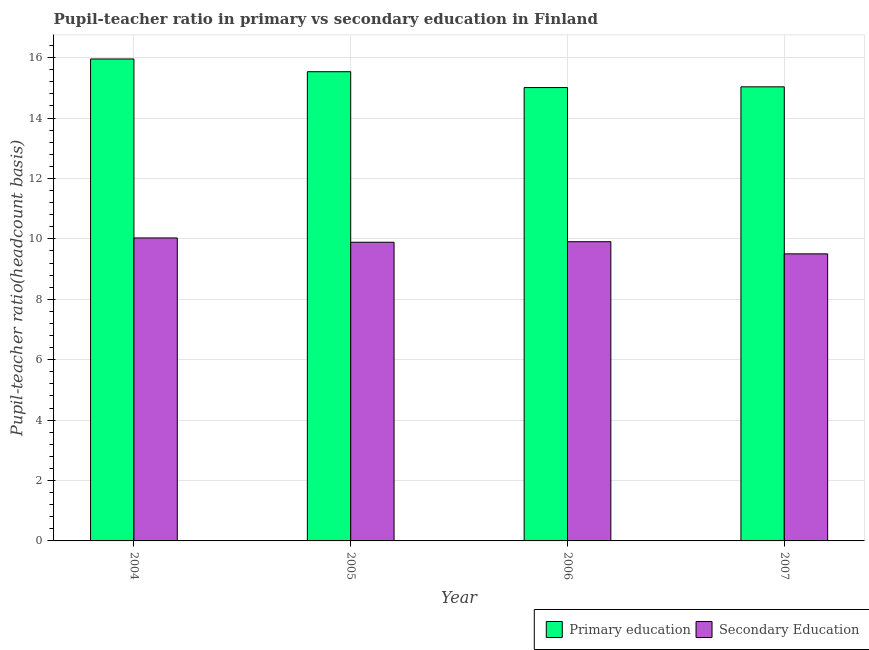How many groups of bars are there?
Offer a very short reply. 4. How many bars are there on the 3rd tick from the left?
Provide a short and direct response. 2. How many bars are there on the 3rd tick from the right?
Give a very brief answer. 2. What is the pupil-teacher ratio in primary education in 2005?
Make the answer very short. 15.53. Across all years, what is the maximum pupil teacher ratio on secondary education?
Make the answer very short. 10.03. Across all years, what is the minimum pupil-teacher ratio in primary education?
Give a very brief answer. 15.01. In which year was the pupil-teacher ratio in primary education maximum?
Ensure brevity in your answer.  2004. What is the total pupil-teacher ratio in primary education in the graph?
Your answer should be very brief. 61.53. What is the difference between the pupil-teacher ratio in primary education in 2004 and that in 2006?
Your response must be concise. 0.95. What is the difference between the pupil teacher ratio on secondary education in 2005 and the pupil-teacher ratio in primary education in 2007?
Your answer should be very brief. 0.38. What is the average pupil teacher ratio on secondary education per year?
Provide a short and direct response. 9.83. In how many years, is the pupil teacher ratio on secondary education greater than 1.6?
Your answer should be compact. 4. What is the ratio of the pupil-teacher ratio in primary education in 2004 to that in 2006?
Make the answer very short. 1.06. Is the pupil teacher ratio on secondary education in 2004 less than that in 2007?
Offer a terse response. No. What is the difference between the highest and the second highest pupil teacher ratio on secondary education?
Offer a terse response. 0.12. What is the difference between the highest and the lowest pupil teacher ratio on secondary education?
Your response must be concise. 0.53. What does the 2nd bar from the right in 2007 represents?
Keep it short and to the point. Primary education. How many years are there in the graph?
Provide a short and direct response. 4. Are the values on the major ticks of Y-axis written in scientific E-notation?
Give a very brief answer. No. Where does the legend appear in the graph?
Offer a very short reply. Bottom right. How many legend labels are there?
Provide a short and direct response. 2. What is the title of the graph?
Provide a short and direct response. Pupil-teacher ratio in primary vs secondary education in Finland. What is the label or title of the Y-axis?
Your answer should be very brief. Pupil-teacher ratio(headcount basis). What is the Pupil-teacher ratio(headcount basis) of Primary education in 2004?
Provide a short and direct response. 15.96. What is the Pupil-teacher ratio(headcount basis) in Secondary Education in 2004?
Keep it short and to the point. 10.03. What is the Pupil-teacher ratio(headcount basis) of Primary education in 2005?
Provide a short and direct response. 15.53. What is the Pupil-teacher ratio(headcount basis) of Secondary Education in 2005?
Ensure brevity in your answer.  9.89. What is the Pupil-teacher ratio(headcount basis) of Primary education in 2006?
Your response must be concise. 15.01. What is the Pupil-teacher ratio(headcount basis) in Secondary Education in 2006?
Your response must be concise. 9.91. What is the Pupil-teacher ratio(headcount basis) in Primary education in 2007?
Provide a succinct answer. 15.03. What is the Pupil-teacher ratio(headcount basis) of Secondary Education in 2007?
Provide a short and direct response. 9.5. Across all years, what is the maximum Pupil-teacher ratio(headcount basis) in Primary education?
Your answer should be compact. 15.96. Across all years, what is the maximum Pupil-teacher ratio(headcount basis) of Secondary Education?
Provide a short and direct response. 10.03. Across all years, what is the minimum Pupil-teacher ratio(headcount basis) of Primary education?
Provide a succinct answer. 15.01. Across all years, what is the minimum Pupil-teacher ratio(headcount basis) in Secondary Education?
Ensure brevity in your answer.  9.5. What is the total Pupil-teacher ratio(headcount basis) in Primary education in the graph?
Provide a short and direct response. 61.53. What is the total Pupil-teacher ratio(headcount basis) in Secondary Education in the graph?
Offer a terse response. 39.33. What is the difference between the Pupil-teacher ratio(headcount basis) in Primary education in 2004 and that in 2005?
Provide a succinct answer. 0.42. What is the difference between the Pupil-teacher ratio(headcount basis) of Secondary Education in 2004 and that in 2005?
Give a very brief answer. 0.14. What is the difference between the Pupil-teacher ratio(headcount basis) of Primary education in 2004 and that in 2006?
Provide a short and direct response. 0.95. What is the difference between the Pupil-teacher ratio(headcount basis) of Secondary Education in 2004 and that in 2006?
Keep it short and to the point. 0.12. What is the difference between the Pupil-teacher ratio(headcount basis) of Primary education in 2004 and that in 2007?
Give a very brief answer. 0.92. What is the difference between the Pupil-teacher ratio(headcount basis) in Secondary Education in 2004 and that in 2007?
Offer a very short reply. 0.53. What is the difference between the Pupil-teacher ratio(headcount basis) in Primary education in 2005 and that in 2006?
Offer a terse response. 0.52. What is the difference between the Pupil-teacher ratio(headcount basis) of Secondary Education in 2005 and that in 2006?
Provide a short and direct response. -0.02. What is the difference between the Pupil-teacher ratio(headcount basis) in Primary education in 2005 and that in 2007?
Your response must be concise. 0.5. What is the difference between the Pupil-teacher ratio(headcount basis) in Secondary Education in 2005 and that in 2007?
Your response must be concise. 0.38. What is the difference between the Pupil-teacher ratio(headcount basis) of Primary education in 2006 and that in 2007?
Provide a succinct answer. -0.02. What is the difference between the Pupil-teacher ratio(headcount basis) in Secondary Education in 2006 and that in 2007?
Give a very brief answer. 0.4. What is the difference between the Pupil-teacher ratio(headcount basis) of Primary education in 2004 and the Pupil-teacher ratio(headcount basis) of Secondary Education in 2005?
Make the answer very short. 6.07. What is the difference between the Pupil-teacher ratio(headcount basis) of Primary education in 2004 and the Pupil-teacher ratio(headcount basis) of Secondary Education in 2006?
Give a very brief answer. 6.05. What is the difference between the Pupil-teacher ratio(headcount basis) in Primary education in 2004 and the Pupil-teacher ratio(headcount basis) in Secondary Education in 2007?
Keep it short and to the point. 6.45. What is the difference between the Pupil-teacher ratio(headcount basis) in Primary education in 2005 and the Pupil-teacher ratio(headcount basis) in Secondary Education in 2006?
Your answer should be compact. 5.63. What is the difference between the Pupil-teacher ratio(headcount basis) in Primary education in 2005 and the Pupil-teacher ratio(headcount basis) in Secondary Education in 2007?
Your answer should be very brief. 6.03. What is the difference between the Pupil-teacher ratio(headcount basis) of Primary education in 2006 and the Pupil-teacher ratio(headcount basis) of Secondary Education in 2007?
Ensure brevity in your answer.  5.51. What is the average Pupil-teacher ratio(headcount basis) in Primary education per year?
Your answer should be very brief. 15.38. What is the average Pupil-teacher ratio(headcount basis) of Secondary Education per year?
Make the answer very short. 9.83. In the year 2004, what is the difference between the Pupil-teacher ratio(headcount basis) of Primary education and Pupil-teacher ratio(headcount basis) of Secondary Education?
Offer a very short reply. 5.93. In the year 2005, what is the difference between the Pupil-teacher ratio(headcount basis) of Primary education and Pupil-teacher ratio(headcount basis) of Secondary Education?
Provide a succinct answer. 5.65. In the year 2006, what is the difference between the Pupil-teacher ratio(headcount basis) of Primary education and Pupil-teacher ratio(headcount basis) of Secondary Education?
Provide a succinct answer. 5.1. In the year 2007, what is the difference between the Pupil-teacher ratio(headcount basis) in Primary education and Pupil-teacher ratio(headcount basis) in Secondary Education?
Make the answer very short. 5.53. What is the ratio of the Pupil-teacher ratio(headcount basis) in Primary education in 2004 to that in 2005?
Provide a succinct answer. 1.03. What is the ratio of the Pupil-teacher ratio(headcount basis) of Secondary Education in 2004 to that in 2005?
Your answer should be compact. 1.01. What is the ratio of the Pupil-teacher ratio(headcount basis) of Primary education in 2004 to that in 2006?
Ensure brevity in your answer.  1.06. What is the ratio of the Pupil-teacher ratio(headcount basis) in Secondary Education in 2004 to that in 2006?
Offer a terse response. 1.01. What is the ratio of the Pupil-teacher ratio(headcount basis) in Primary education in 2004 to that in 2007?
Offer a terse response. 1.06. What is the ratio of the Pupil-teacher ratio(headcount basis) of Secondary Education in 2004 to that in 2007?
Make the answer very short. 1.06. What is the ratio of the Pupil-teacher ratio(headcount basis) of Primary education in 2005 to that in 2006?
Offer a very short reply. 1.03. What is the ratio of the Pupil-teacher ratio(headcount basis) of Secondary Education in 2005 to that in 2006?
Offer a very short reply. 1. What is the ratio of the Pupil-teacher ratio(headcount basis) in Primary education in 2005 to that in 2007?
Make the answer very short. 1.03. What is the ratio of the Pupil-teacher ratio(headcount basis) of Secondary Education in 2005 to that in 2007?
Make the answer very short. 1.04. What is the ratio of the Pupil-teacher ratio(headcount basis) in Secondary Education in 2006 to that in 2007?
Offer a very short reply. 1.04. What is the difference between the highest and the second highest Pupil-teacher ratio(headcount basis) in Primary education?
Provide a short and direct response. 0.42. What is the difference between the highest and the second highest Pupil-teacher ratio(headcount basis) in Secondary Education?
Give a very brief answer. 0.12. What is the difference between the highest and the lowest Pupil-teacher ratio(headcount basis) of Primary education?
Offer a terse response. 0.95. What is the difference between the highest and the lowest Pupil-teacher ratio(headcount basis) in Secondary Education?
Provide a succinct answer. 0.53. 